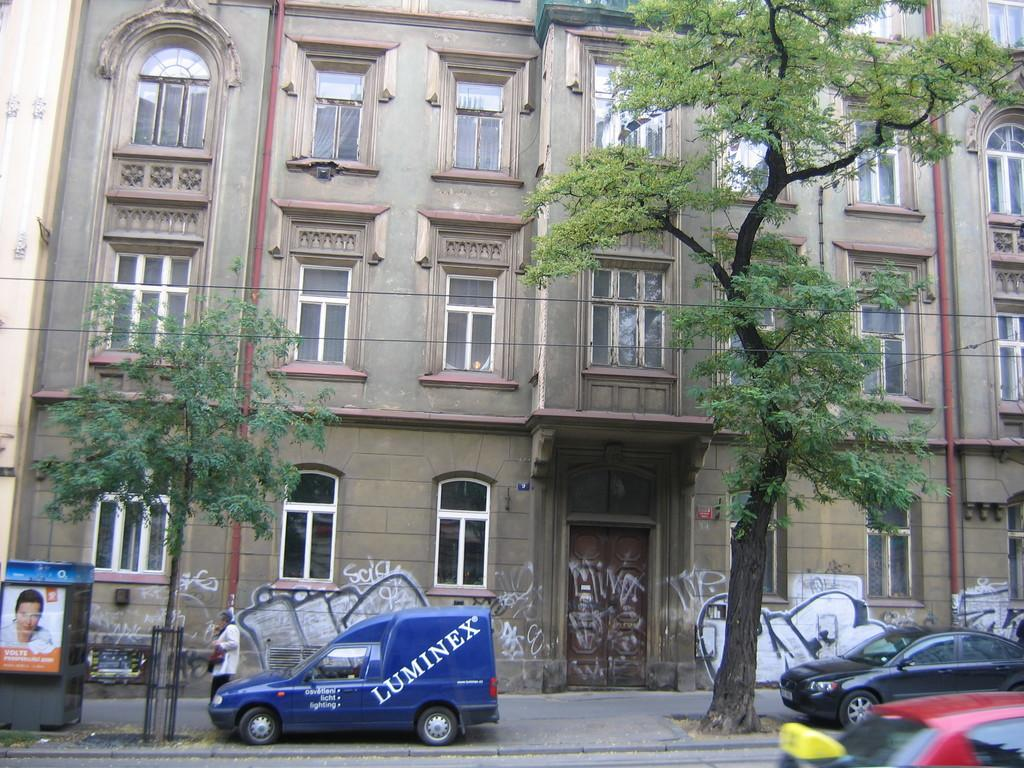<image>
Summarize the visual content of the image. an outside of a building with a blue van outside of it that says 'luminex' 